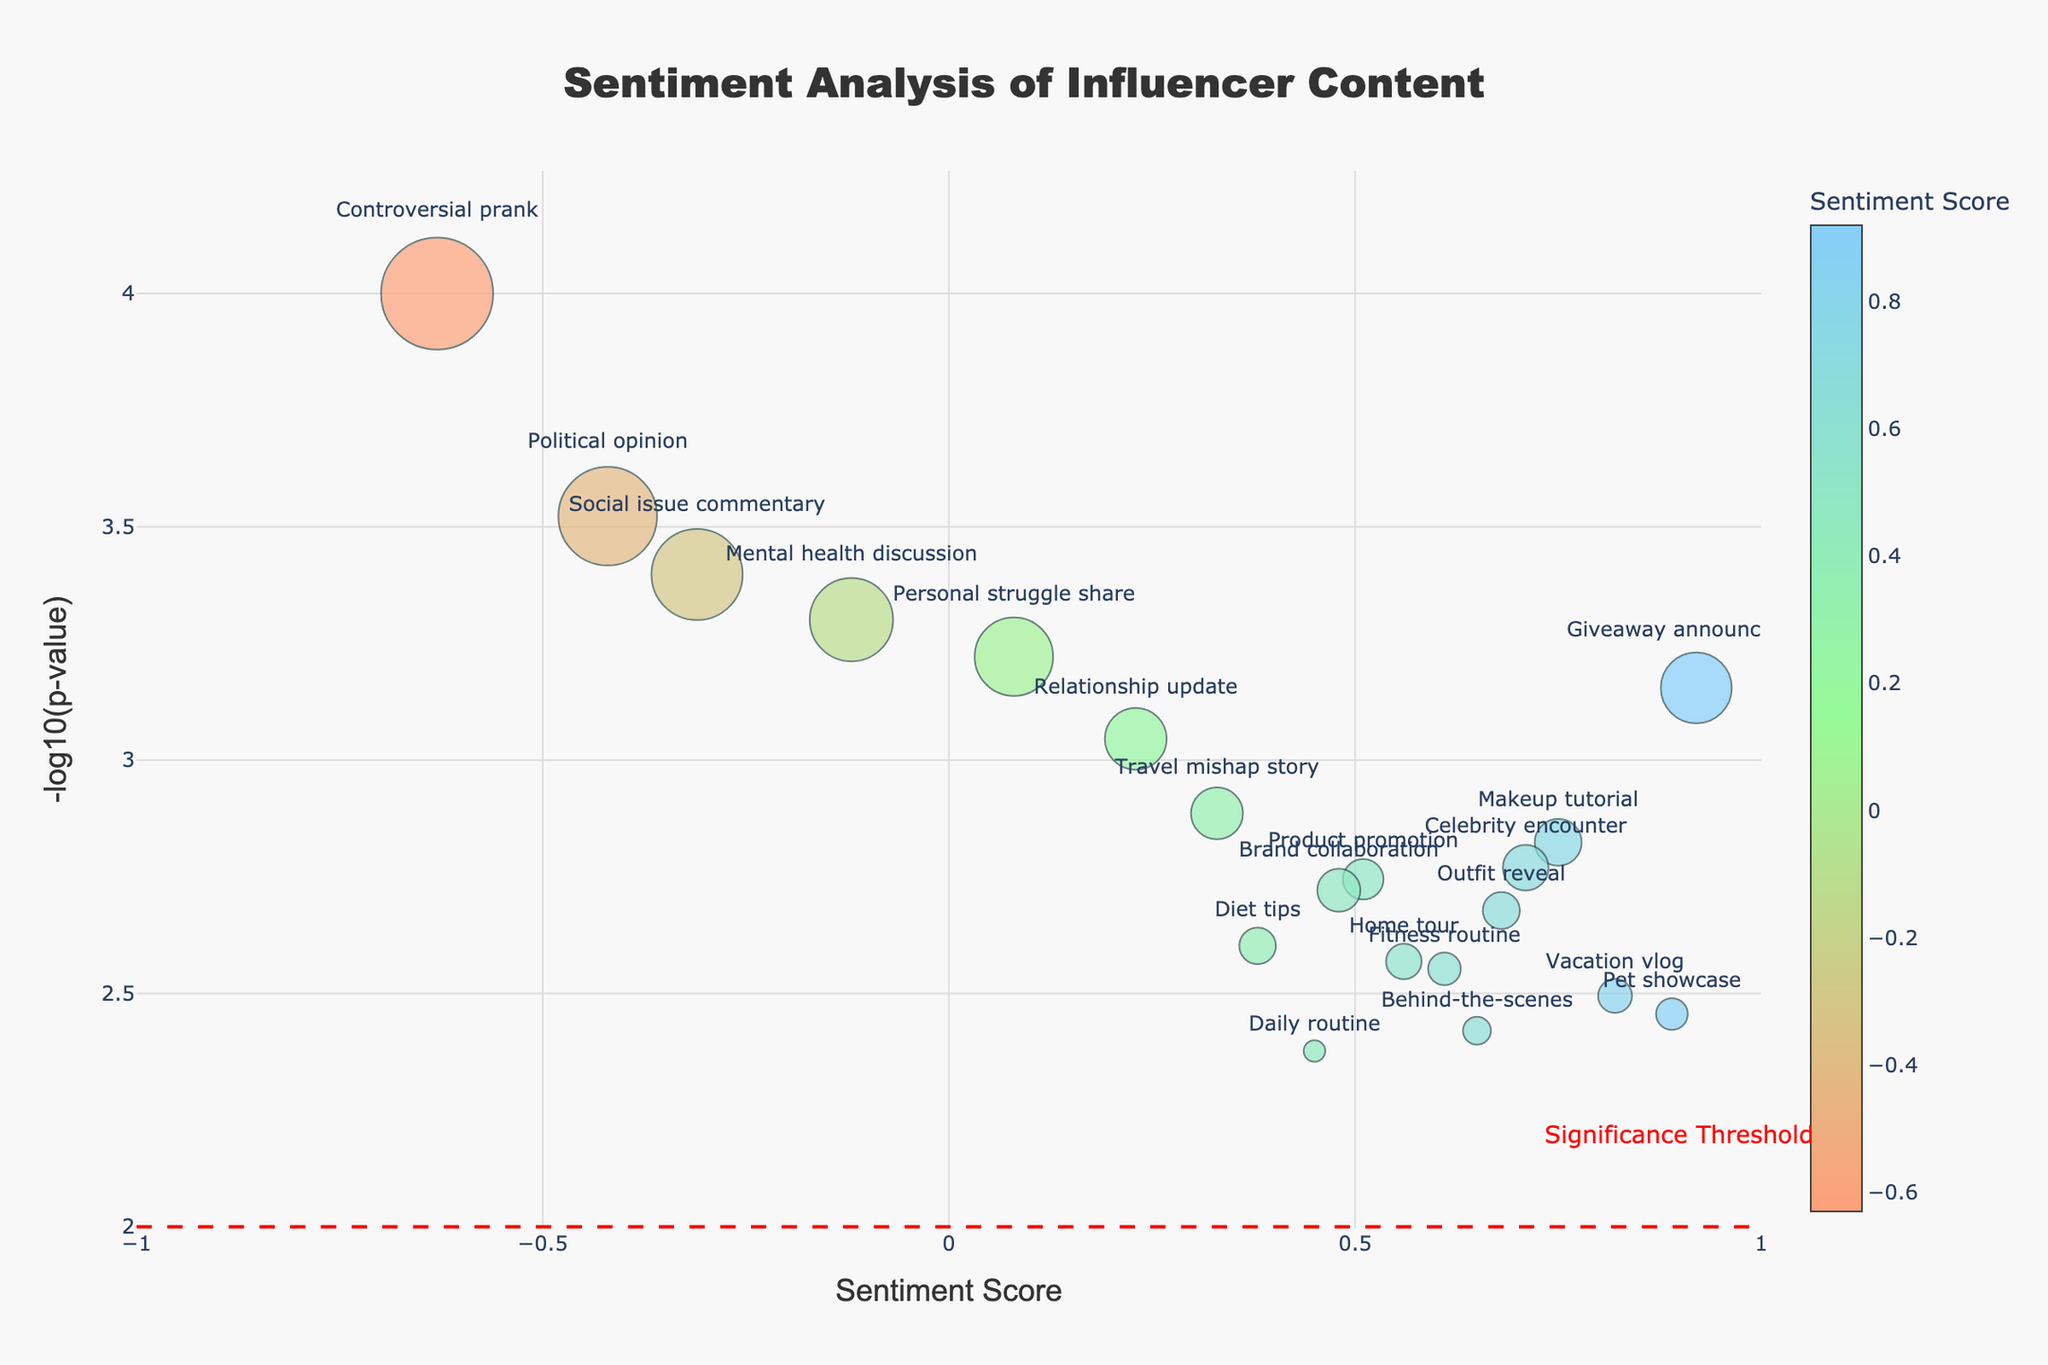What is the title of the plot? The title is displayed prominently at the top of the plot.
Answer: Sentiment Analysis of Influencer Content How many data points are there in the plot? Count the number of markers (circles) on the plot, each representing a different post.
Answer: 20 Which post has the highest comment frequency? Look for the largest marker on the plot, as marker size is proportional to comment frequency.
Answer: Controversial prank What is the sentiment score range shown on the x-axis? Examine the x-axis range provided in the plot's layout.
Answer: -1 to 1 Which post has the most negative sentiment score? Find the marker with the lowest x-axis value (most negative sentiment score).
Answer: Controversial prank What is the lowest p-value among the posts? The lowest p-value will correspond to the highest value on the y-axis due to the -log10 transformation.
Answer: 0.0001 Compare the sentiment scores of "Makeup tutorial" and "Political opinion." Which has a higher score? Check the x-axis values for both posts and compare them.
Answer: Makeup tutorial Which post type is closest to the significance threshold line at -log10(p-value) = 2? Identify the marker closest to the red dashed line on the y-axis at the value of 2.
Answer: Behind-the-scenes Is there any controversial content with a positive sentiment score? Locate posts categorized as controversial. Then, check if any have positive x-axis values.
Answer: No Among non-controversial posts, which has the highest sentiment score? Identify non-controversial post markers and find the one with the highest x-axis value.
Answer: Giveaway announcement 